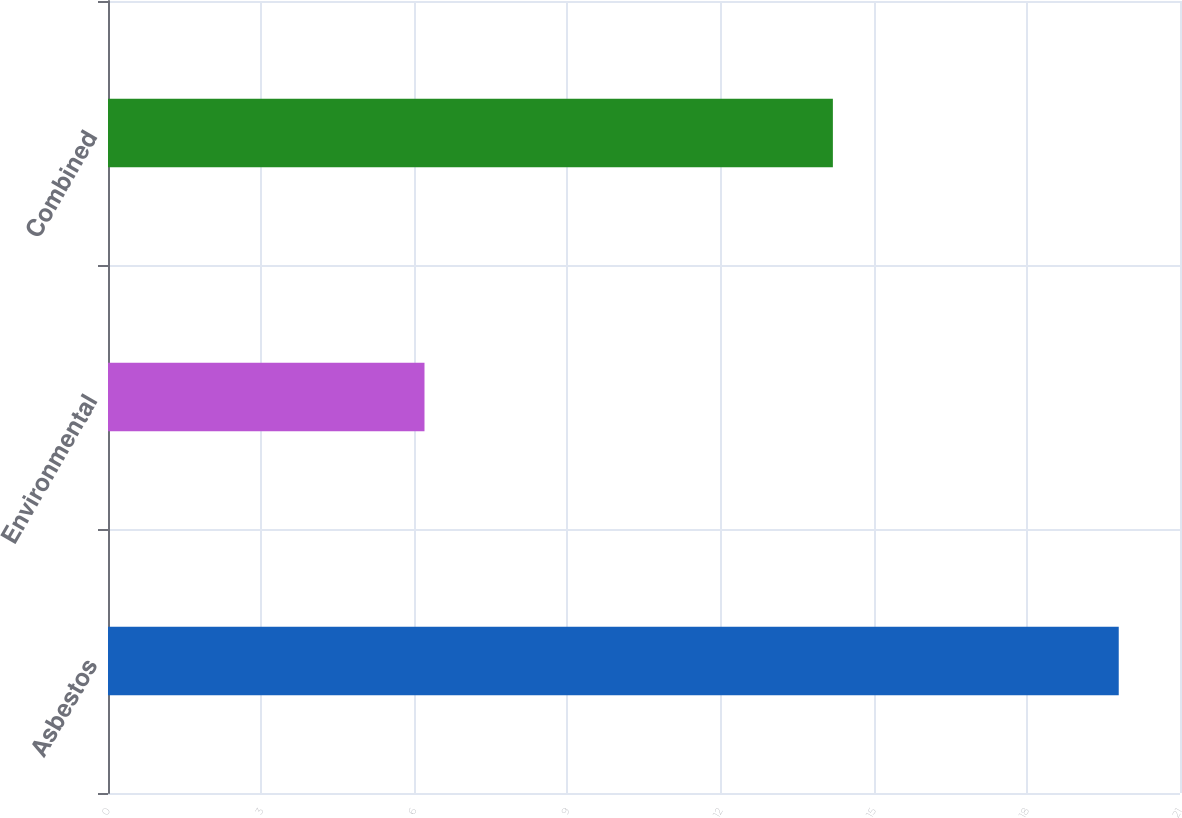Convert chart. <chart><loc_0><loc_0><loc_500><loc_500><bar_chart><fcel>Asbestos<fcel>Environmental<fcel>Combined<nl><fcel>19.8<fcel>6.2<fcel>14.2<nl></chart> 